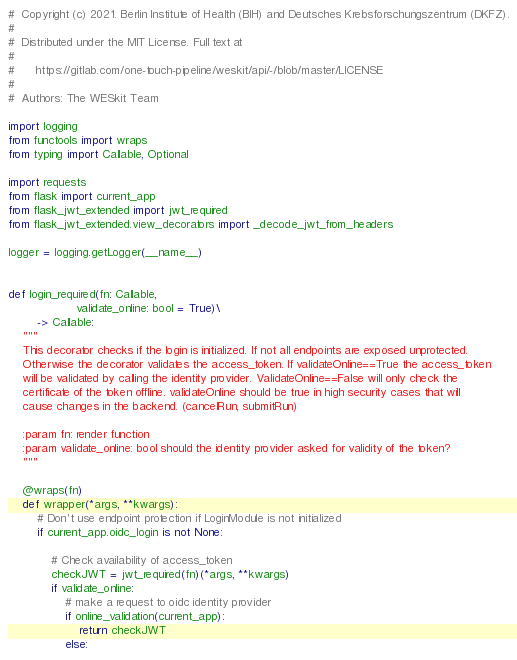Convert code to text. <code><loc_0><loc_0><loc_500><loc_500><_Python_>#  Copyright (c) 2021. Berlin Institute of Health (BIH) and Deutsches Krebsforschungszentrum (DKFZ).
#
#  Distributed under the MIT License. Full text at
#
#      https://gitlab.com/one-touch-pipeline/weskit/api/-/blob/master/LICENSE
#
#  Authors: The WESkit Team

import logging
from functools import wraps
from typing import Callable, Optional

import requests
from flask import current_app
from flask_jwt_extended import jwt_required
from flask_jwt_extended.view_decorators import _decode_jwt_from_headers

logger = logging.getLogger(__name__)


def login_required(fn: Callable,
                   validate_online: bool = True)\
        -> Callable:
    """
    This decorator checks if the login is initialized. If not all endpoints are exposed unprotected.
    Otherwise the decorator validates the access_token. If validateOnline==True the access_token
    will be validated by calling the identity provider. ValidateOnline==False will only check the
    certificate of the token offline. validateOnline should be true in high security cases that will
    cause changes in the backend. (cancelRun, submitRun)

    :param fn: render function
    :param validate_online: bool should the identity provider asked for validity of the token?
    """

    @wraps(fn)
    def wrapper(*args, **kwargs):
        # Don't use endpoint protection if LoginModule is not initialized
        if current_app.oidc_login is not None:

            # Check availability of access_token
            checkJWT = jwt_required(fn)(*args, **kwargs)
            if validate_online:
                # make a request to oidc identity provider
                if online_validation(current_app):
                    return checkJWT
                else:</code> 